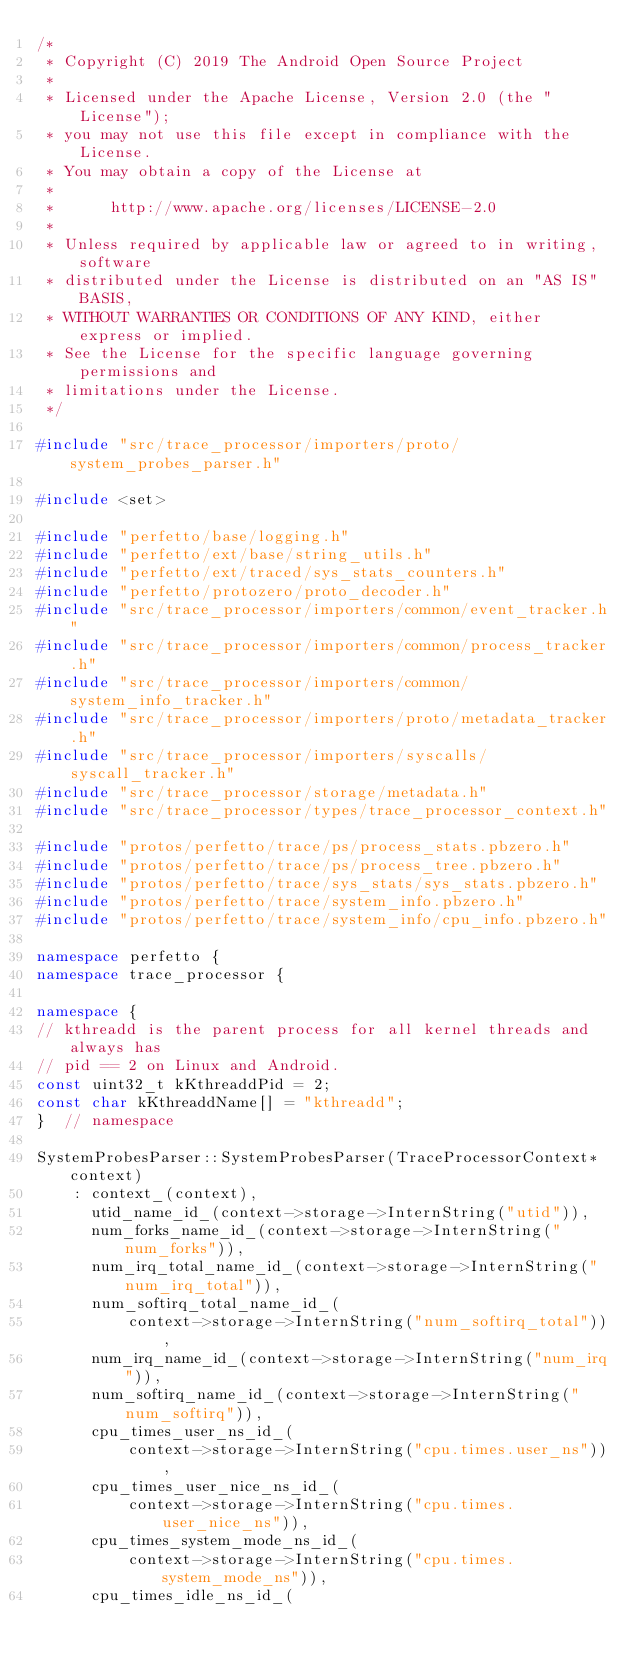Convert code to text. <code><loc_0><loc_0><loc_500><loc_500><_C++_>/*
 * Copyright (C) 2019 The Android Open Source Project
 *
 * Licensed under the Apache License, Version 2.0 (the "License");
 * you may not use this file except in compliance with the License.
 * You may obtain a copy of the License at
 *
 *      http://www.apache.org/licenses/LICENSE-2.0
 *
 * Unless required by applicable law or agreed to in writing, software
 * distributed under the License is distributed on an "AS IS" BASIS,
 * WITHOUT WARRANTIES OR CONDITIONS OF ANY KIND, either express or implied.
 * See the License for the specific language governing permissions and
 * limitations under the License.
 */

#include "src/trace_processor/importers/proto/system_probes_parser.h"

#include <set>

#include "perfetto/base/logging.h"
#include "perfetto/ext/base/string_utils.h"
#include "perfetto/ext/traced/sys_stats_counters.h"
#include "perfetto/protozero/proto_decoder.h"
#include "src/trace_processor/importers/common/event_tracker.h"
#include "src/trace_processor/importers/common/process_tracker.h"
#include "src/trace_processor/importers/common/system_info_tracker.h"
#include "src/trace_processor/importers/proto/metadata_tracker.h"
#include "src/trace_processor/importers/syscalls/syscall_tracker.h"
#include "src/trace_processor/storage/metadata.h"
#include "src/trace_processor/types/trace_processor_context.h"

#include "protos/perfetto/trace/ps/process_stats.pbzero.h"
#include "protos/perfetto/trace/ps/process_tree.pbzero.h"
#include "protos/perfetto/trace/sys_stats/sys_stats.pbzero.h"
#include "protos/perfetto/trace/system_info.pbzero.h"
#include "protos/perfetto/trace/system_info/cpu_info.pbzero.h"

namespace perfetto {
namespace trace_processor {

namespace {
// kthreadd is the parent process for all kernel threads and always has
// pid == 2 on Linux and Android.
const uint32_t kKthreaddPid = 2;
const char kKthreaddName[] = "kthreadd";
}  // namespace

SystemProbesParser::SystemProbesParser(TraceProcessorContext* context)
    : context_(context),
      utid_name_id_(context->storage->InternString("utid")),
      num_forks_name_id_(context->storage->InternString("num_forks")),
      num_irq_total_name_id_(context->storage->InternString("num_irq_total")),
      num_softirq_total_name_id_(
          context->storage->InternString("num_softirq_total")),
      num_irq_name_id_(context->storage->InternString("num_irq")),
      num_softirq_name_id_(context->storage->InternString("num_softirq")),
      cpu_times_user_ns_id_(
          context->storage->InternString("cpu.times.user_ns")),
      cpu_times_user_nice_ns_id_(
          context->storage->InternString("cpu.times.user_nice_ns")),
      cpu_times_system_mode_ns_id_(
          context->storage->InternString("cpu.times.system_mode_ns")),
      cpu_times_idle_ns_id_(</code> 